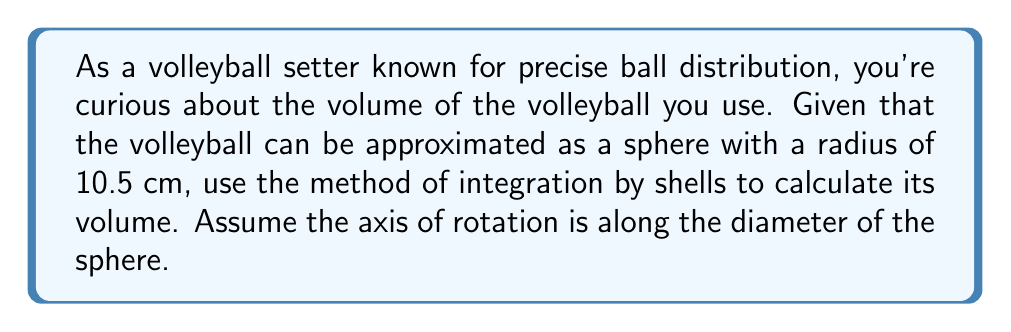Could you help me with this problem? To solve this problem using the method of integration by shells, we'll follow these steps:

1) First, let's visualize the problem. We're rotating a semicircle around its diameter to form a sphere.

2) The equation of a circle with radius $r$ centered at the origin is:

   $$x^2 + y^2 = r^2$$

3) Solving for $y$:

   $$y = \sqrt{r^2 - x^2}$$

4) The volume formula using the method of shells is:

   $$V = 2\pi \int_0^r x \cdot h(x) \, dx$$

   where $x$ is the radius of each shell and $h(x)$ is the height of each shell.

5) In our case, $h(x) = 2y = 2\sqrt{r^2 - x^2}$, and $r = 10.5$ cm.

6) Substituting into our volume formula:

   $$V = 2\pi \int_0^{10.5} x \cdot 2\sqrt{10.5^2 - x^2} \, dx$$

7) Simplifying:

   $$V = 4\pi \int_0^{10.5} x \sqrt{10.5^2 - x^2} \, dx$$

8) This integral can be solved using trigonometric substitution, but we can also recognize that this is the standard form for the volume of a sphere. The result is:

   $$V = \frac{4}{3}\pi r^3$$

9) Plugging in our radius:

   $$V = \frac{4}{3}\pi (10.5)^3 \approx 4850.45 \, \text{cm}^3$$
Answer: The volume of the volleyball is approximately 4850.45 cubic centimeters. 